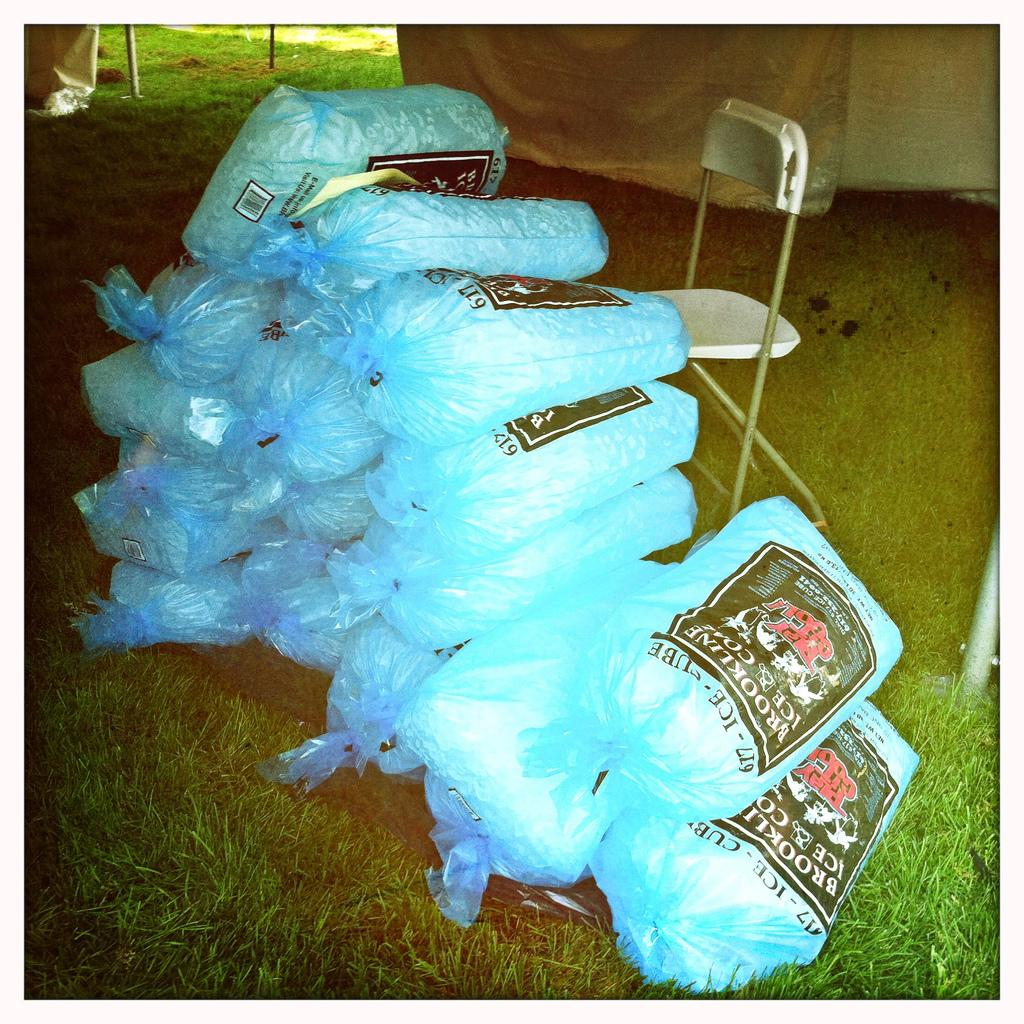What is located in the center of the picture? There are objects in bags in the center of the picture. Can you describe any furniture in the image? Yes, there is a chair in the picture. What type of natural environment is visible in the foreground? Grass is visible in the foreground. What structures can be seen at the top of the image? There are tents and iron poles at the top of the image. What type of vegetation is visible at the top of the image? Grass is visible at the top of the image. What type of collar can be seen on the dog in the image? There is no dog or collar present in the image. What discovery was made by the explorers in the image? There are no explorers or discoveries mentioned in the image. 